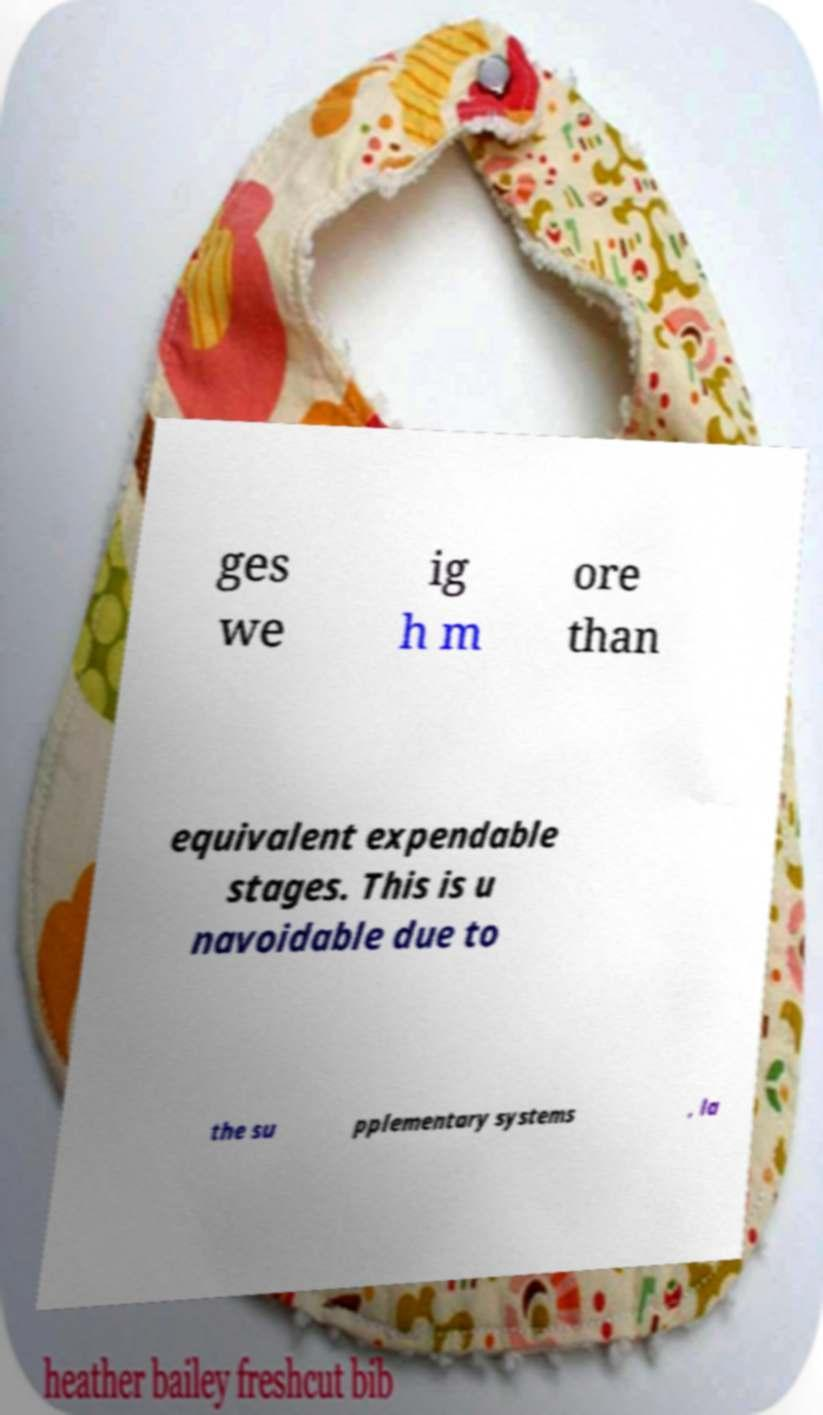I need the written content from this picture converted into text. Can you do that? ges we ig h m ore than equivalent expendable stages. This is u navoidable due to the su pplementary systems , la 